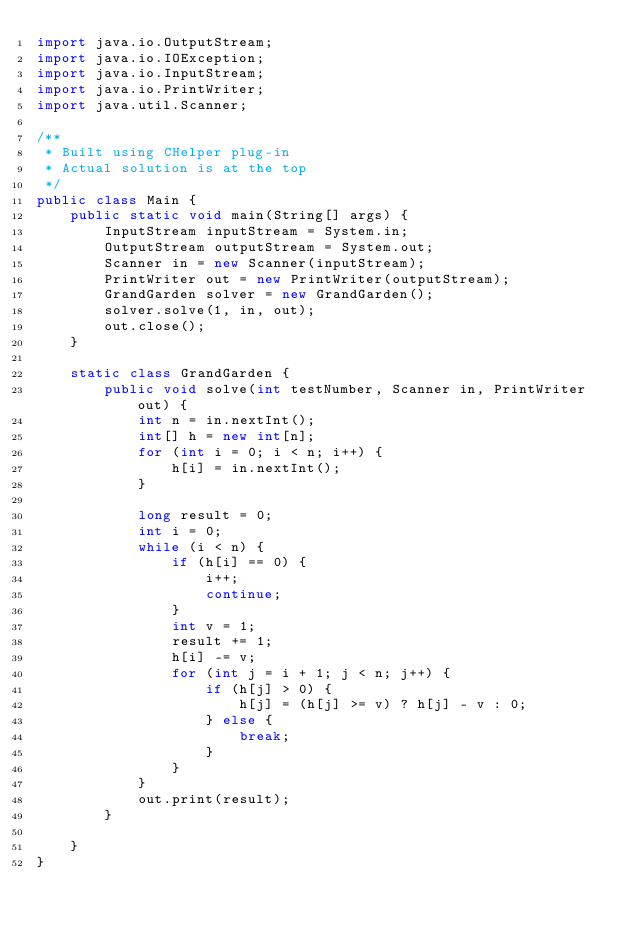Convert code to text. <code><loc_0><loc_0><loc_500><loc_500><_Java_>import java.io.OutputStream;
import java.io.IOException;
import java.io.InputStream;
import java.io.PrintWriter;
import java.util.Scanner;

/**
 * Built using CHelper plug-in
 * Actual solution is at the top
 */
public class Main {
    public static void main(String[] args) {
        InputStream inputStream = System.in;
        OutputStream outputStream = System.out;
        Scanner in = new Scanner(inputStream);
        PrintWriter out = new PrintWriter(outputStream);
        GrandGarden solver = new GrandGarden();
        solver.solve(1, in, out);
        out.close();
    }

    static class GrandGarden {
        public void solve(int testNumber, Scanner in, PrintWriter out) {
            int n = in.nextInt();
            int[] h = new int[n];
            for (int i = 0; i < n; i++) {
                h[i] = in.nextInt();
            }

            long result = 0;
            int i = 0;
            while (i < n) {
                if (h[i] == 0) {
                    i++;
                    continue;
                }
                int v = 1;
                result += 1;
                h[i] -= v;
                for (int j = i + 1; j < n; j++) {
                    if (h[j] > 0) {
                        h[j] = (h[j] >= v) ? h[j] - v : 0;
                    } else {
                        break;
                    }
                }
            }
            out.print(result);
        }

    }
}

</code> 